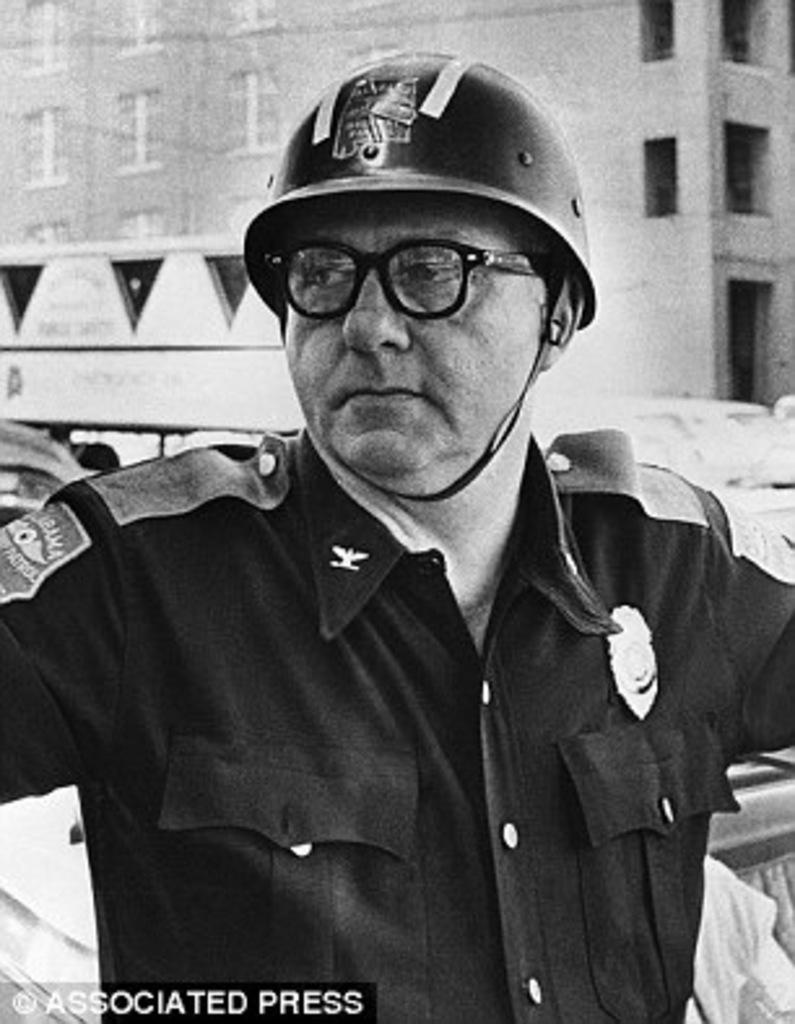What is the color scheme of the image? The image is black and white. Who is present in the image? There is a man in the image. What is the man wearing on his face? The man is wearing glasses (specs) in the image. What type of protective gear is the man wearing on his head? The man is wearing a helmet in the image. What can be seen in the background of the image? There is a building in the background of the image. What is written or displayed at the bottom of the image? There is text at the bottom of the image. How many circles can be seen in the image? There are no circles present in the image. What type of wall is visible in the image? There is no wall visible in the image; only a building in the background. 